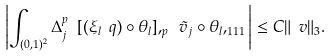<formula> <loc_0><loc_0><loc_500><loc_500>\left | \int _ { ( 0 , 1 ) ^ { 2 } } \Delta _ { j } ^ { p } \ [ ( \xi _ { l } \ q ) \circ \theta _ { l } ] , _ { p } \ { \tilde { v } } _ { j } \circ \theta _ { l } , _ { 1 1 1 } \right | \leq C \| \ v \| _ { 3 } .</formula> 